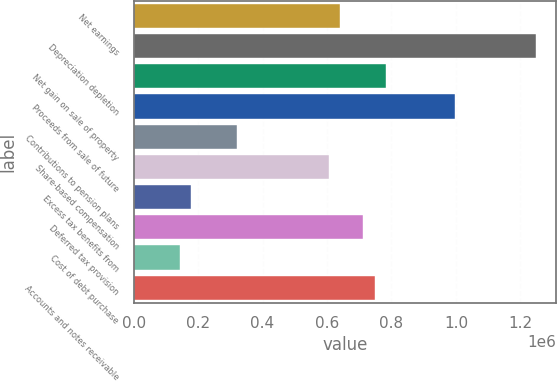<chart> <loc_0><loc_0><loc_500><loc_500><bar_chart><fcel>Net earnings<fcel>Depreciation depletion<fcel>Net gain on sale of property<fcel>Proceeds from sale of future<fcel>Contributions to pension plans<fcel>Share-based compensation<fcel>Excess tax benefits from<fcel>Deferred tax provision<fcel>Cost of debt purchase<fcel>Accounts and notes receivable<nl><fcel>641697<fcel>1.24774e+06<fcel>784296<fcel>998195<fcel>320849<fcel>606047<fcel>178250<fcel>712997<fcel>142600<fcel>748646<nl></chart> 